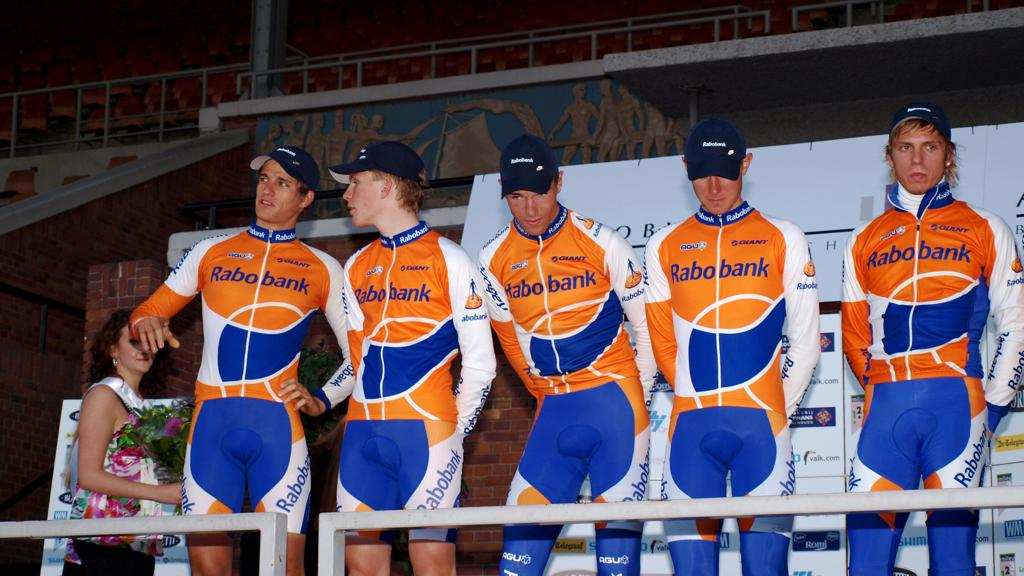<image>
Create a compact narrative representing the image presented. Five men wearing a jumpsuit with Rabo bank written on it. 